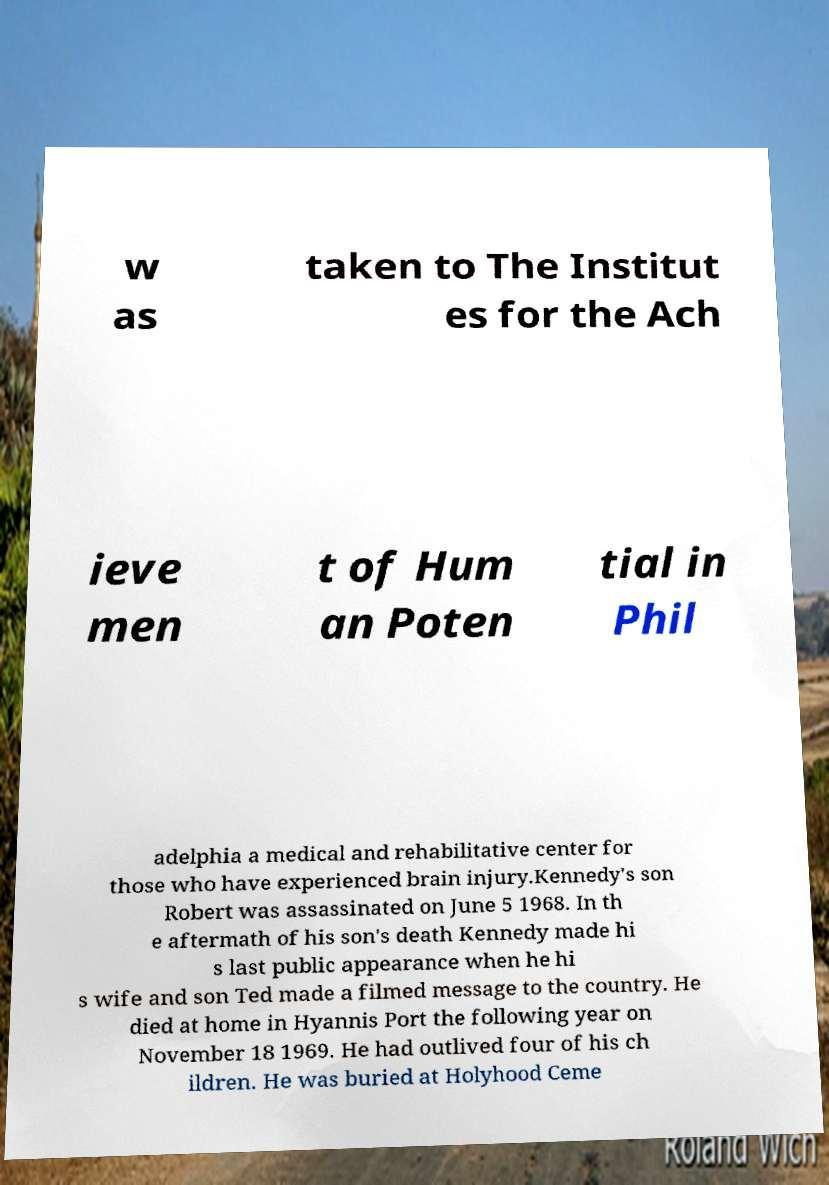For documentation purposes, I need the text within this image transcribed. Could you provide that? w as taken to The Institut es for the Ach ieve men t of Hum an Poten tial in Phil adelphia a medical and rehabilitative center for those who have experienced brain injury.Kennedy's son Robert was assassinated on June 5 1968. In th e aftermath of his son's death Kennedy made hi s last public appearance when he hi s wife and son Ted made a filmed message to the country. He died at home in Hyannis Port the following year on November 18 1969. He had outlived four of his ch ildren. He was buried at Holyhood Ceme 